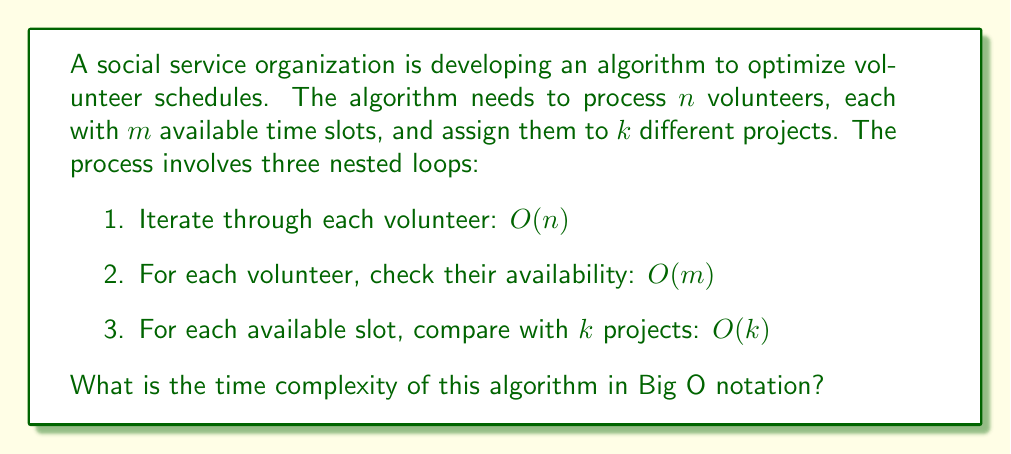Can you solve this math problem? To determine the time complexity of this algorithm, we need to analyze the nested structure of the loops:

1. The outermost loop iterates through all $n$ volunteers: $O(n)$

2. For each volunteer, we check $m$ available time slots: $O(m)$

3. For each available slot, we compare with $k$ projects: $O(k)$

Since these loops are nested, we multiply their individual complexities:

$$O(n) \cdot O(m) \cdot O(k) = O(nmk)$$

This result, $O(nmk)$, represents the worst-case time complexity of the algorithm. It means that the runtime grows linearly with the number of volunteers $(n)$, the number of time slots $(m)$, and the number of projects $(k)$.

In the context of social service organizations, this algorithm's efficiency becomes crucial when dealing with large numbers of volunteers, extensive availability options, or numerous projects. For example, if the organization doubles the number of volunteers, time slots, or projects, the runtime would increase by a factor of 2. If all three parameters double, the runtime would increase by a factor of 8.

It's important to note that while this algorithm provides a comprehensive approach to scheduling, its cubic time complexity might become a bottleneck for very large-scale operations. In such cases, more advanced optimization techniques or approximation algorithms might be necessary to improve efficiency while maintaining the quality of volunteer assignments.
Answer: $O(nmk)$ 